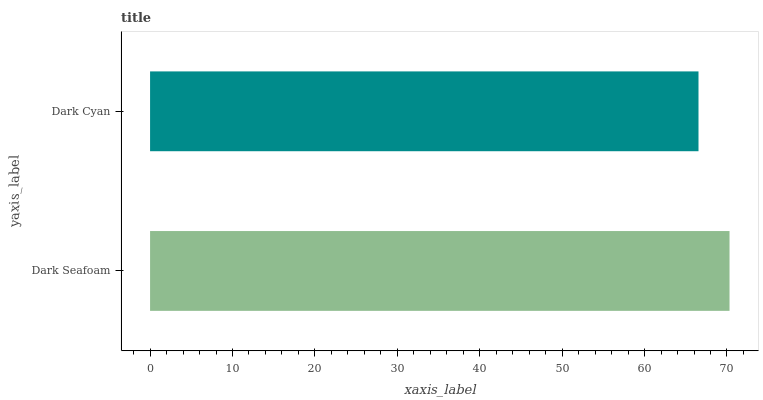Is Dark Cyan the minimum?
Answer yes or no. Yes. Is Dark Seafoam the maximum?
Answer yes or no. Yes. Is Dark Cyan the maximum?
Answer yes or no. No. Is Dark Seafoam greater than Dark Cyan?
Answer yes or no. Yes. Is Dark Cyan less than Dark Seafoam?
Answer yes or no. Yes. Is Dark Cyan greater than Dark Seafoam?
Answer yes or no. No. Is Dark Seafoam less than Dark Cyan?
Answer yes or no. No. Is Dark Seafoam the high median?
Answer yes or no. Yes. Is Dark Cyan the low median?
Answer yes or no. Yes. Is Dark Cyan the high median?
Answer yes or no. No. Is Dark Seafoam the low median?
Answer yes or no. No. 